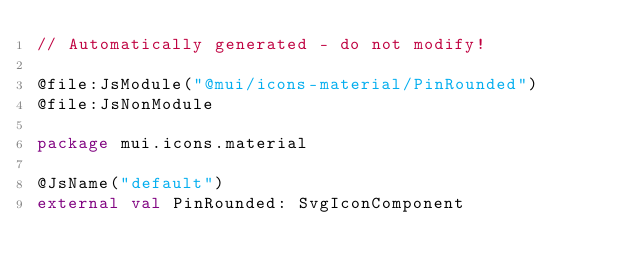<code> <loc_0><loc_0><loc_500><loc_500><_Kotlin_>// Automatically generated - do not modify!

@file:JsModule("@mui/icons-material/PinRounded")
@file:JsNonModule

package mui.icons.material

@JsName("default")
external val PinRounded: SvgIconComponent
</code> 